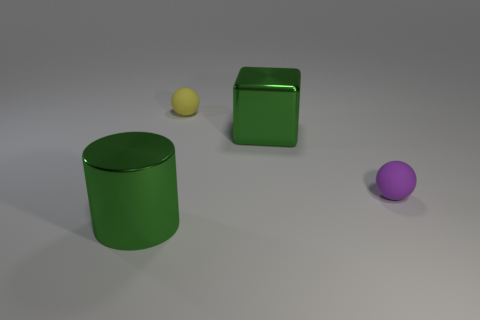Add 1 tiny cylinders. How many objects exist? 5 Subtract all cylinders. How many objects are left? 3 Subtract all big metallic things. Subtract all purple objects. How many objects are left? 1 Add 2 matte balls. How many matte balls are left? 4 Add 3 small objects. How many small objects exist? 5 Subtract 0 cyan spheres. How many objects are left? 4 